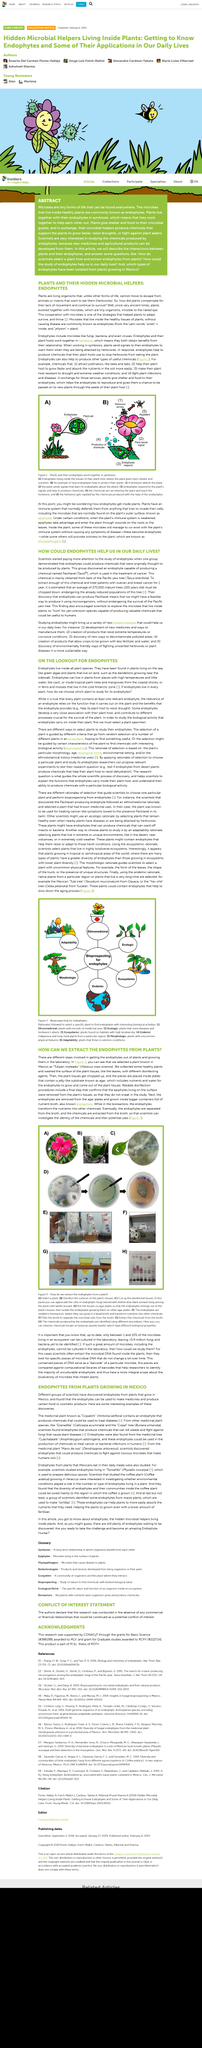Point out several critical features in this image. Granadilla and the Copal tree are medicinal plants that contain endophytes that produce chemicals that are effective in killing weeds and inhibiting the growth of fungi that cause plant diseases. Phytopathogens are the agents that cause sickness in plants. The second step in extracting endophytes from a plant is to disinfect the surfaces of the plant tissue. The first step in extracting endophytes from a plant is selecting a suitable plant sample. It is possible to derive medicinal and agricultural benefits from the chemical compounds produced by endophytes, which are microorganisms that inhabit the plant tissue and root systems of certain species of plants. 